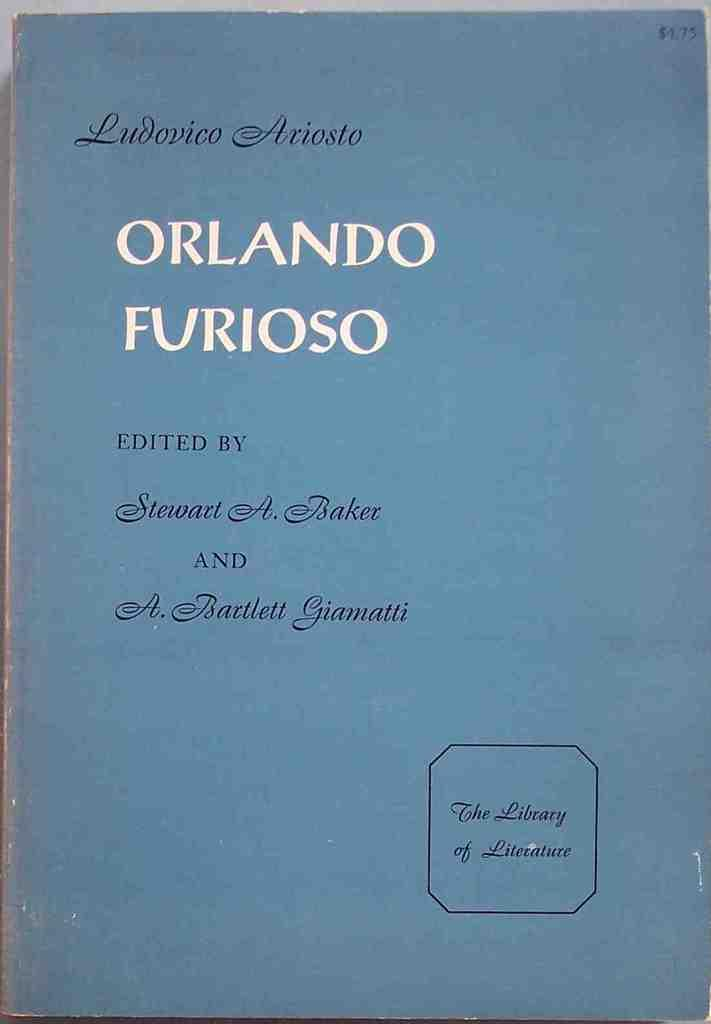<image>
Present a compact description of the photo's key features. Orlando Furioso blue cover hard copy book from the Librabry of Literature. 